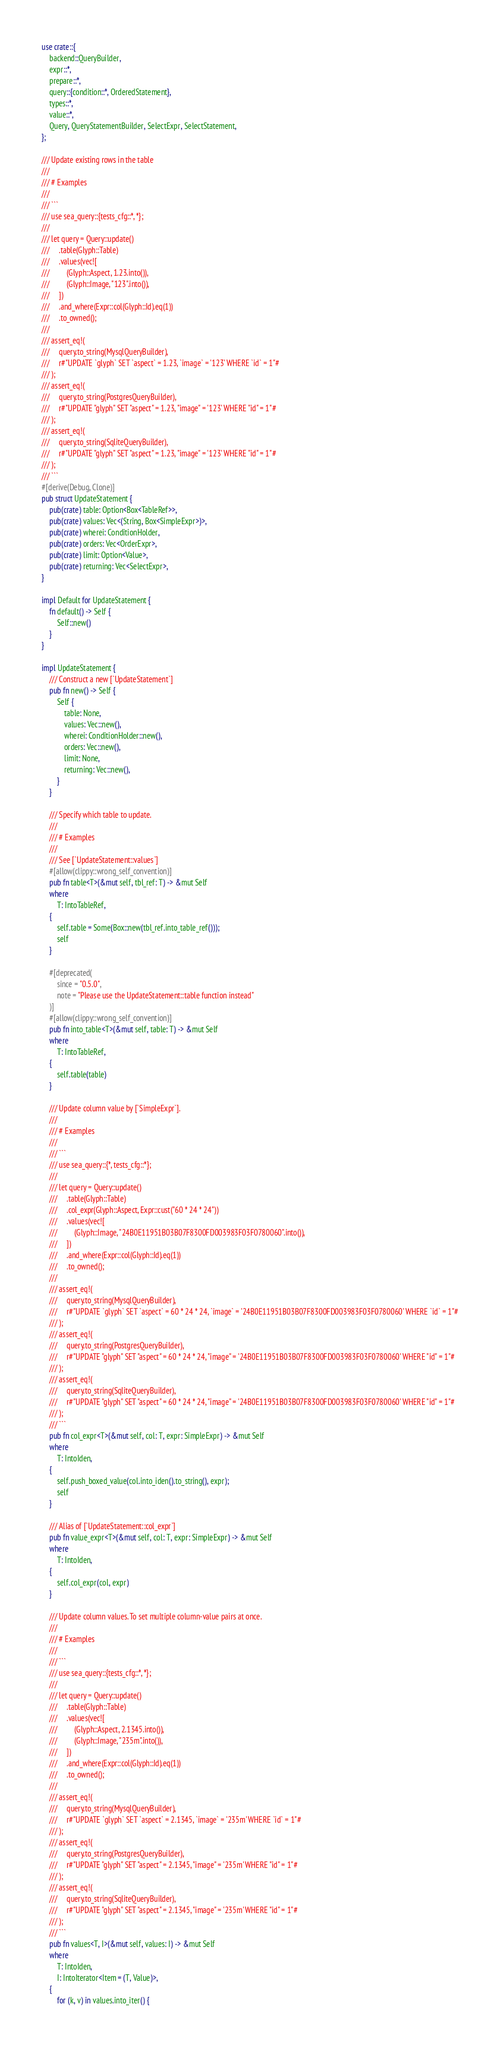<code> <loc_0><loc_0><loc_500><loc_500><_Rust_>use crate::{
    backend::QueryBuilder,
    expr::*,
    prepare::*,
    query::{condition::*, OrderedStatement},
    types::*,
    value::*,
    Query, QueryStatementBuilder, SelectExpr, SelectStatement,
};

/// Update existing rows in the table
///
/// # Examples
///
/// ```
/// use sea_query::{tests_cfg::*, *};
///
/// let query = Query::update()
///     .table(Glyph::Table)
///     .values(vec![
///         (Glyph::Aspect, 1.23.into()),
///         (Glyph::Image, "123".into()),
///     ])
///     .and_where(Expr::col(Glyph::Id).eq(1))
///     .to_owned();
///
/// assert_eq!(
///     query.to_string(MysqlQueryBuilder),
///     r#"UPDATE `glyph` SET `aspect` = 1.23, `image` = '123' WHERE `id` = 1"#
/// );
/// assert_eq!(
///     query.to_string(PostgresQueryBuilder),
///     r#"UPDATE "glyph" SET "aspect" = 1.23, "image" = '123' WHERE "id" = 1"#
/// );
/// assert_eq!(
///     query.to_string(SqliteQueryBuilder),
///     r#"UPDATE "glyph" SET "aspect" = 1.23, "image" = '123' WHERE "id" = 1"#
/// );
/// ```
#[derive(Debug, Clone)]
pub struct UpdateStatement {
    pub(crate) table: Option<Box<TableRef>>,
    pub(crate) values: Vec<(String, Box<SimpleExpr>)>,
    pub(crate) wherei: ConditionHolder,
    pub(crate) orders: Vec<OrderExpr>,
    pub(crate) limit: Option<Value>,
    pub(crate) returning: Vec<SelectExpr>,
}

impl Default for UpdateStatement {
    fn default() -> Self {
        Self::new()
    }
}

impl UpdateStatement {
    /// Construct a new [`UpdateStatement`]
    pub fn new() -> Self {
        Self {
            table: None,
            values: Vec::new(),
            wherei: ConditionHolder::new(),
            orders: Vec::new(),
            limit: None,
            returning: Vec::new(),
        }
    }

    /// Specify which table to update.
    ///
    /// # Examples
    ///
    /// See [`UpdateStatement::values`]
    #[allow(clippy::wrong_self_convention)]
    pub fn table<T>(&mut self, tbl_ref: T) -> &mut Self
    where
        T: IntoTableRef,
    {
        self.table = Some(Box::new(tbl_ref.into_table_ref()));
        self
    }

    #[deprecated(
        since = "0.5.0",
        note = "Please use the UpdateStatement::table function instead"
    )]
    #[allow(clippy::wrong_self_convention)]
    pub fn into_table<T>(&mut self, table: T) -> &mut Self
    where
        T: IntoTableRef,
    {
        self.table(table)
    }

    /// Update column value by [`SimpleExpr`].
    ///
    /// # Examples
    ///
    /// ```
    /// use sea_query::{*, tests_cfg::*};
    ///
    /// let query = Query::update()
    ///     .table(Glyph::Table)
    ///     .col_expr(Glyph::Aspect, Expr::cust("60 * 24 * 24"))
    ///     .values(vec![
    ///         (Glyph::Image, "24B0E11951B03B07F8300FD003983F03F0780060".into()),
    ///     ])
    ///     .and_where(Expr::col(Glyph::Id).eq(1))
    ///     .to_owned();
    ///
    /// assert_eq!(
    ///     query.to_string(MysqlQueryBuilder),
    ///     r#"UPDATE `glyph` SET `aspect` = 60 * 24 * 24, `image` = '24B0E11951B03B07F8300FD003983F03F0780060' WHERE `id` = 1"#
    /// );
    /// assert_eq!(
    ///     query.to_string(PostgresQueryBuilder),
    ///     r#"UPDATE "glyph" SET "aspect" = 60 * 24 * 24, "image" = '24B0E11951B03B07F8300FD003983F03F0780060' WHERE "id" = 1"#
    /// );
    /// assert_eq!(
    ///     query.to_string(SqliteQueryBuilder),
    ///     r#"UPDATE "glyph" SET "aspect" = 60 * 24 * 24, "image" = '24B0E11951B03B07F8300FD003983F03F0780060' WHERE "id" = 1"#
    /// );
    /// ```
    pub fn col_expr<T>(&mut self, col: T, expr: SimpleExpr) -> &mut Self
    where
        T: IntoIden,
    {
        self.push_boxed_value(col.into_iden().to_string(), expr);
        self
    }

    /// Alias of [`UpdateStatement::col_expr`]
    pub fn value_expr<T>(&mut self, col: T, expr: SimpleExpr) -> &mut Self
    where
        T: IntoIden,
    {
        self.col_expr(col, expr)
    }

    /// Update column values. To set multiple column-value pairs at once.
    ///
    /// # Examples
    ///
    /// ```
    /// use sea_query::{tests_cfg::*, *};
    ///
    /// let query = Query::update()
    ///     .table(Glyph::Table)
    ///     .values(vec![
    ///         (Glyph::Aspect, 2.1345.into()),
    ///         (Glyph::Image, "235m".into()),
    ///     ])
    ///     .and_where(Expr::col(Glyph::Id).eq(1))
    ///     .to_owned();
    ///
    /// assert_eq!(
    ///     query.to_string(MysqlQueryBuilder),
    ///     r#"UPDATE `glyph` SET `aspect` = 2.1345, `image` = '235m' WHERE `id` = 1"#
    /// );
    /// assert_eq!(
    ///     query.to_string(PostgresQueryBuilder),
    ///     r#"UPDATE "glyph" SET "aspect" = 2.1345, "image" = '235m' WHERE "id" = 1"#
    /// );
    /// assert_eq!(
    ///     query.to_string(SqliteQueryBuilder),
    ///     r#"UPDATE "glyph" SET "aspect" = 2.1345, "image" = '235m' WHERE "id" = 1"#
    /// );
    /// ```
    pub fn values<T, I>(&mut self, values: I) -> &mut Self
    where
        T: IntoIden,
        I: IntoIterator<Item = (T, Value)>,
    {
        for (k, v) in values.into_iter() {</code> 